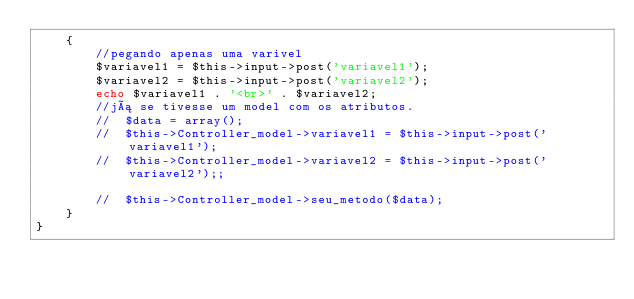<code> <loc_0><loc_0><loc_500><loc_500><_PHP_>    {
        //pegando apenas uma varivel
        $variavel1 = $this->input->post('variavel1');
        $variavel2 = $this->input->post('variavel2');
        echo $variavel1 . '<br>' . $variavel2;
        //já se tivesse um model com os atributos.
        //  $data = array();
        //	$this->Controller_model->variavel1 = $this->input->post('variavel1');
        //	$this->Controller_model->variavel2 = $this->input->post('variavel2');;

        //	$this->Controller_model->seu_metodo($data);
    }
}
</code> 